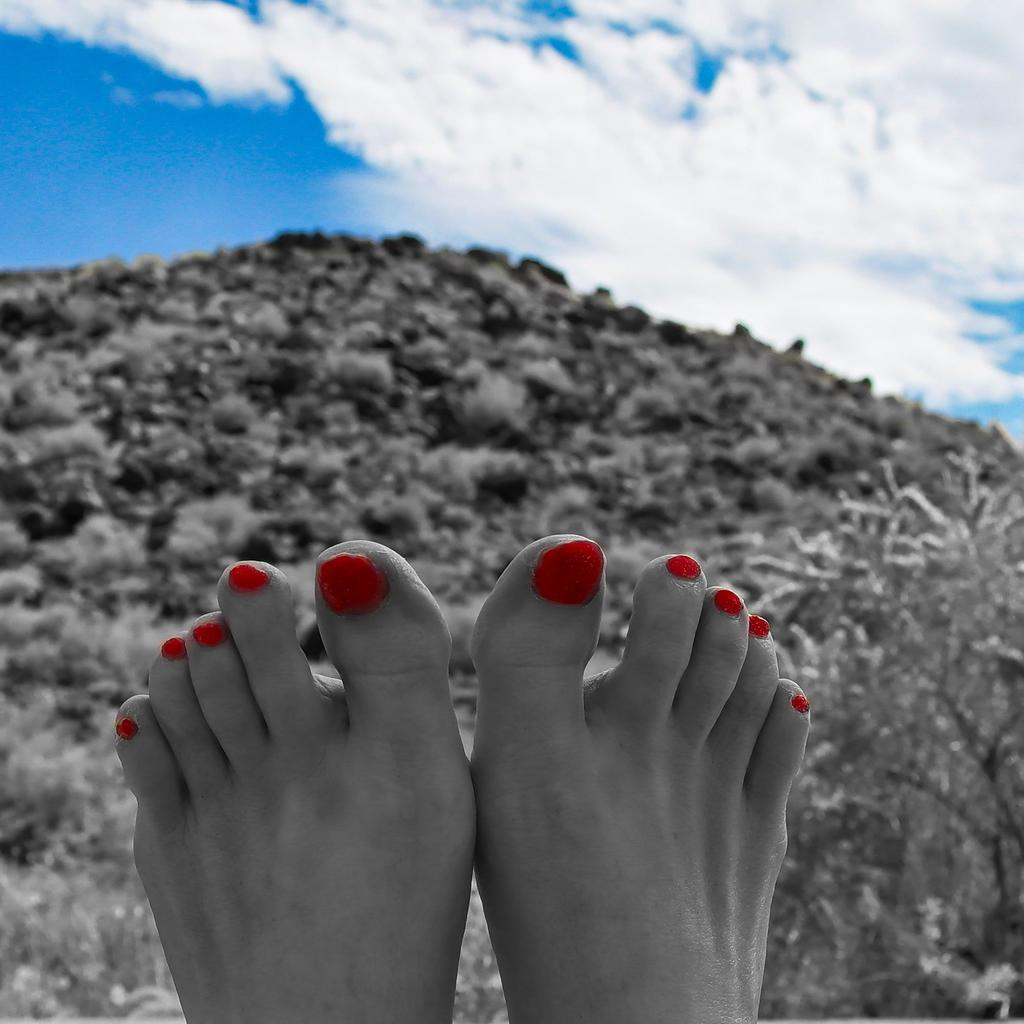What is the main focus of the image? The main focus of the image is a close view of a girl's legs. What can be observed about the girl's nails in the image? The girl's nails have red nail polish. What is visible in the background of the image? There is a mountain in the background of the image, with grass visible near the mountain. What is visible at the top of the image? The sky is visible at the top of the image, with clouds present. What type of cat can be seen playing with the queen in the image? There is no cat or queen present in the image; it features a close view of a girl's legs. How many dogs are visible near the mountain in the image? There are no dogs visible in the image; only a mountain, grass, and the sky are present. 